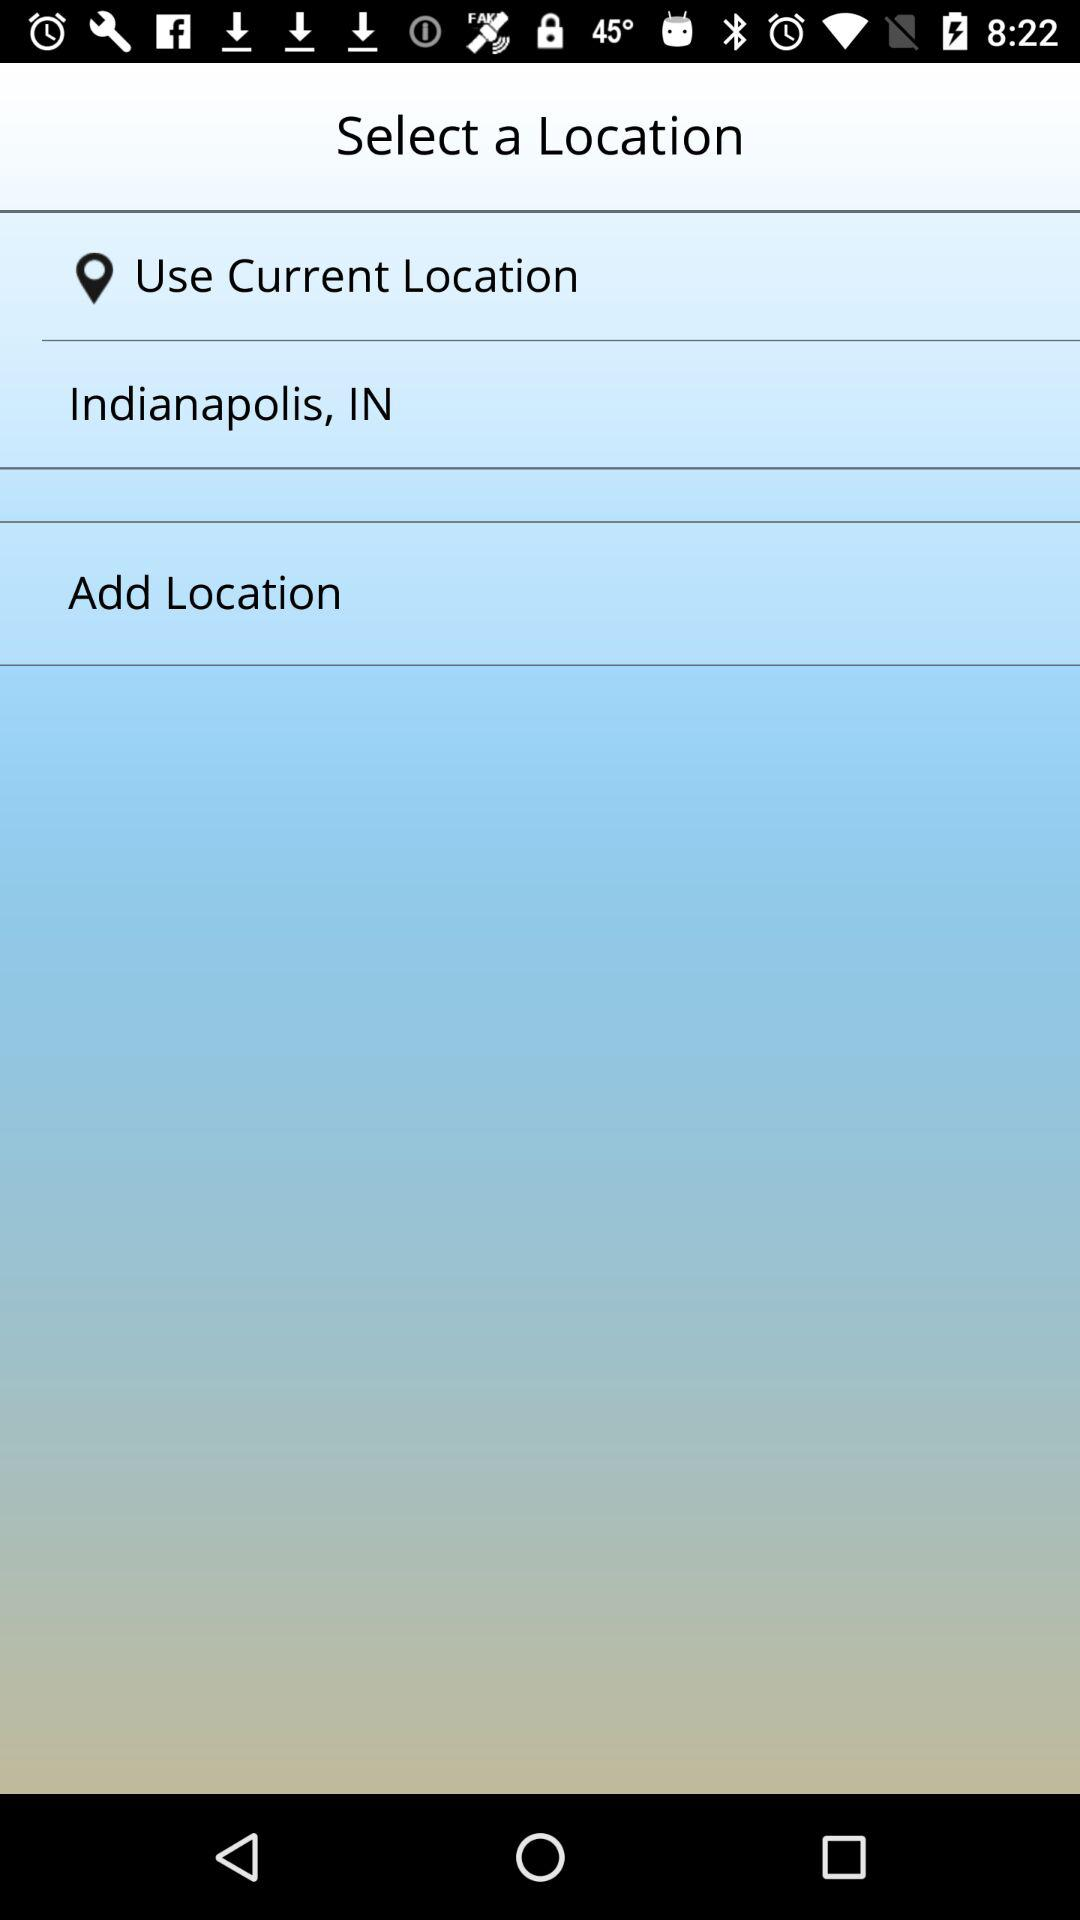How many locations are available to select?
Answer the question using a single word or phrase. 2 